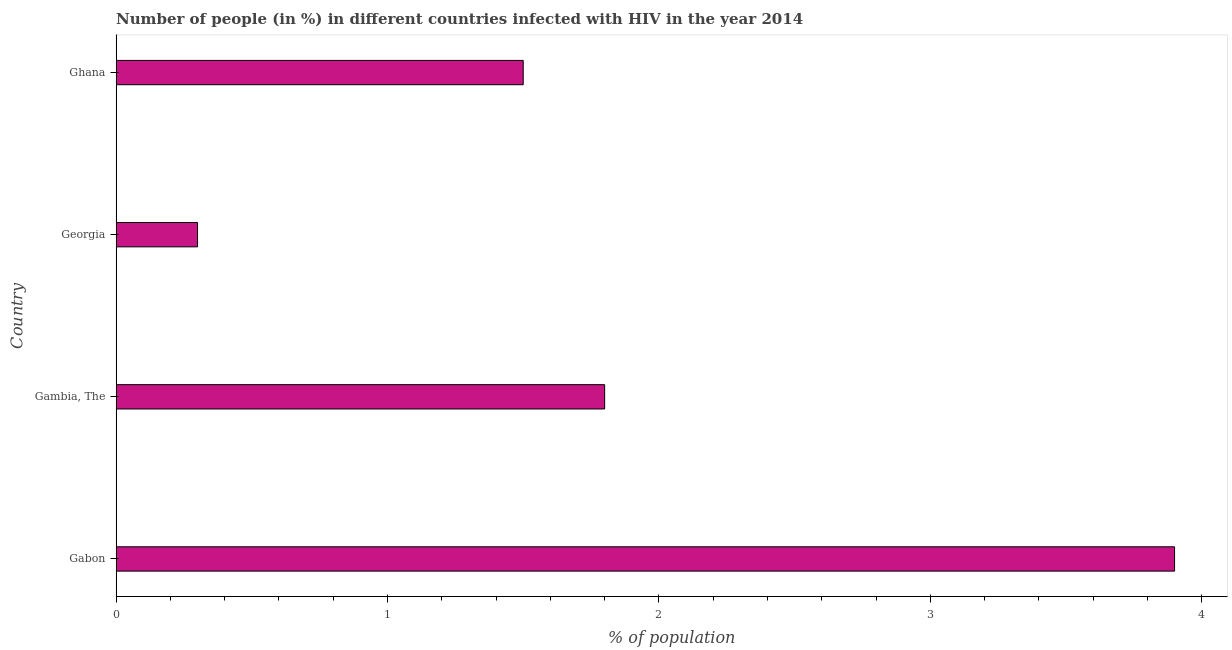What is the title of the graph?
Keep it short and to the point. Number of people (in %) in different countries infected with HIV in the year 2014. What is the label or title of the X-axis?
Offer a very short reply. % of population. What is the label or title of the Y-axis?
Keep it short and to the point. Country. Across all countries, what is the maximum number of people infected with hiv?
Offer a terse response. 3.9. Across all countries, what is the minimum number of people infected with hiv?
Your response must be concise. 0.3. In which country was the number of people infected with hiv maximum?
Offer a terse response. Gabon. In which country was the number of people infected with hiv minimum?
Make the answer very short. Georgia. What is the difference between the number of people infected with hiv in Gambia, The and Ghana?
Your answer should be compact. 0.3. What is the average number of people infected with hiv per country?
Ensure brevity in your answer.  1.88. What is the median number of people infected with hiv?
Your answer should be very brief. 1.65. Is the number of people infected with hiv in Gabon less than that in Gambia, The?
Make the answer very short. No. Is the sum of the number of people infected with hiv in Gabon and Gambia, The greater than the maximum number of people infected with hiv across all countries?
Keep it short and to the point. Yes. What is the difference between the highest and the lowest number of people infected with hiv?
Offer a very short reply. 3.6. What is the difference between two consecutive major ticks on the X-axis?
Ensure brevity in your answer.  1. Are the values on the major ticks of X-axis written in scientific E-notation?
Offer a very short reply. No. What is the % of population of Gabon?
Provide a succinct answer. 3.9. What is the % of population in Gambia, The?
Your answer should be compact. 1.8. What is the % of population in Georgia?
Give a very brief answer. 0.3. What is the difference between the % of population in Gabon and Gambia, The?
Provide a succinct answer. 2.1. What is the difference between the % of population in Gambia, The and Georgia?
Provide a short and direct response. 1.5. What is the difference between the % of population in Gambia, The and Ghana?
Provide a succinct answer. 0.3. What is the ratio of the % of population in Gabon to that in Gambia, The?
Your answer should be compact. 2.17. What is the ratio of the % of population in Gabon to that in Georgia?
Ensure brevity in your answer.  13. What is the ratio of the % of population in Gabon to that in Ghana?
Offer a terse response. 2.6. 